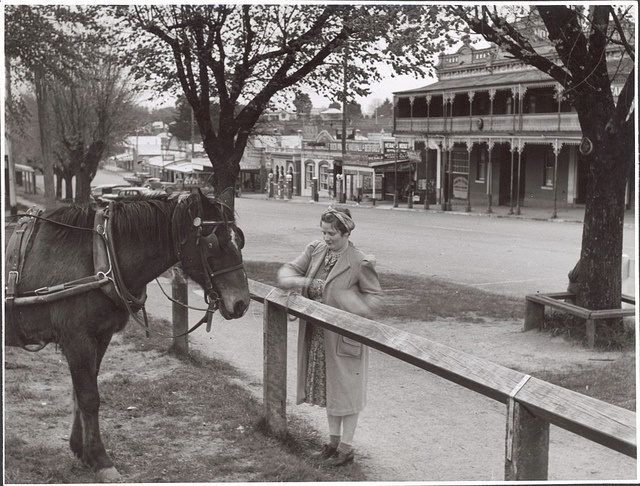Describe the objects in this image and their specific colors. I can see horse in darkgray, black, and gray tones and people in darkgray, gray, and black tones in this image. 